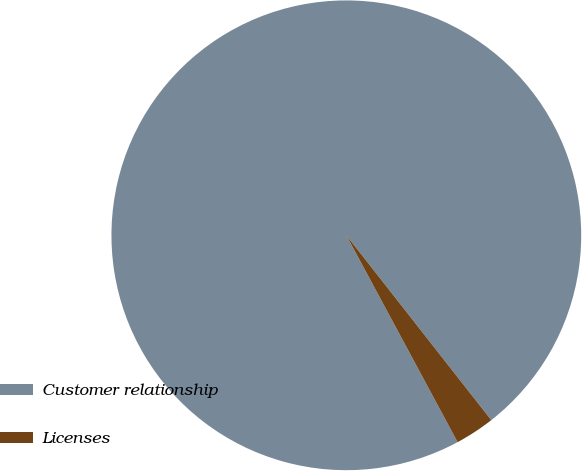Convert chart. <chart><loc_0><loc_0><loc_500><loc_500><pie_chart><fcel>Customer relationship<fcel>Licenses<nl><fcel>97.27%<fcel>2.73%<nl></chart> 